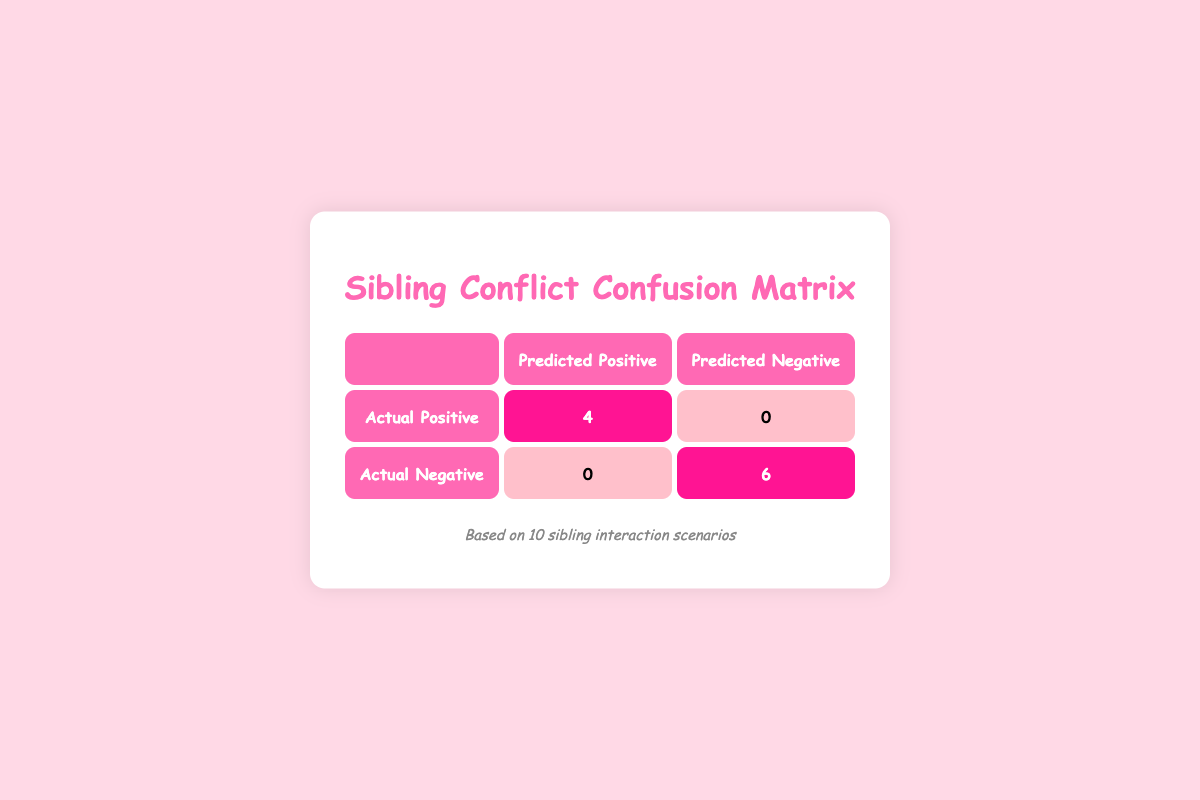What is the total number of positive outcomes? By looking at the table, we can see there are 4 predicted positives for actual positives and 0 predicted positives for actual negatives. Therefore, the total number of positive outcomes is 4.
Answer: 4 How many negative outcomes were there? The table shows 0 predicted negatives for actual positives and 6 predicted negatives for actual negatives, hence the total number of negative outcomes is 6.
Answer: 6 Is it true that all predicted positive outcomes were actual positive outcomes? According to the table, there are 4 actual positives and 0 actual negatives that predicted positive outcomes, which means yes, all predicted positives were actual positives.
Answer: Yes What proportion of the outcomes were negative? To find the proportion, we sum the positive and negative outcomes: 4 (positive) + 6 (negative) = 10 total outcomes. Now, the proportion of negative outcomes is 6/10, which simplifies to 0.6 or 60%.
Answer: 60% What is the ratio of positive to negative outcomes? The number of positive outcomes is 4, while the number of negative outcomes is 6. This gives a ratio of 4:6, which simplifies to 2:3 by dividing both numbers by 2.
Answer: 2:3 How many total predicted outcomes are accounted for in the matrix? To find the total predicted outcomes, we add the predicted outcomes for actual positives and actual negatives: (4 + 0) + (0 + 6) = 10 total predicted outcomes.
Answer: 10 What is the total number of actual positive reactions? Based on the table, there are 4 actual positive reactions indicated in the cell for "Actual Positive" and "Predicted Positive." Therefore, the total number of actual positive reactions is 4.
Answer: 4 Which outcome type had the highest count, positive or negative? The table indicates that there are 4 positive outcomes and 6 negative outcomes. Since 6 is greater than 4, negative outcomes had the highest count.
Answer: Negative Was there any instance where a predicted positive outcome was actually negative? The table shows that there are no instances where a predicted positive outcome was actually negative (0 predicted positives for actual negatives), which means the answer is no.
Answer: No 